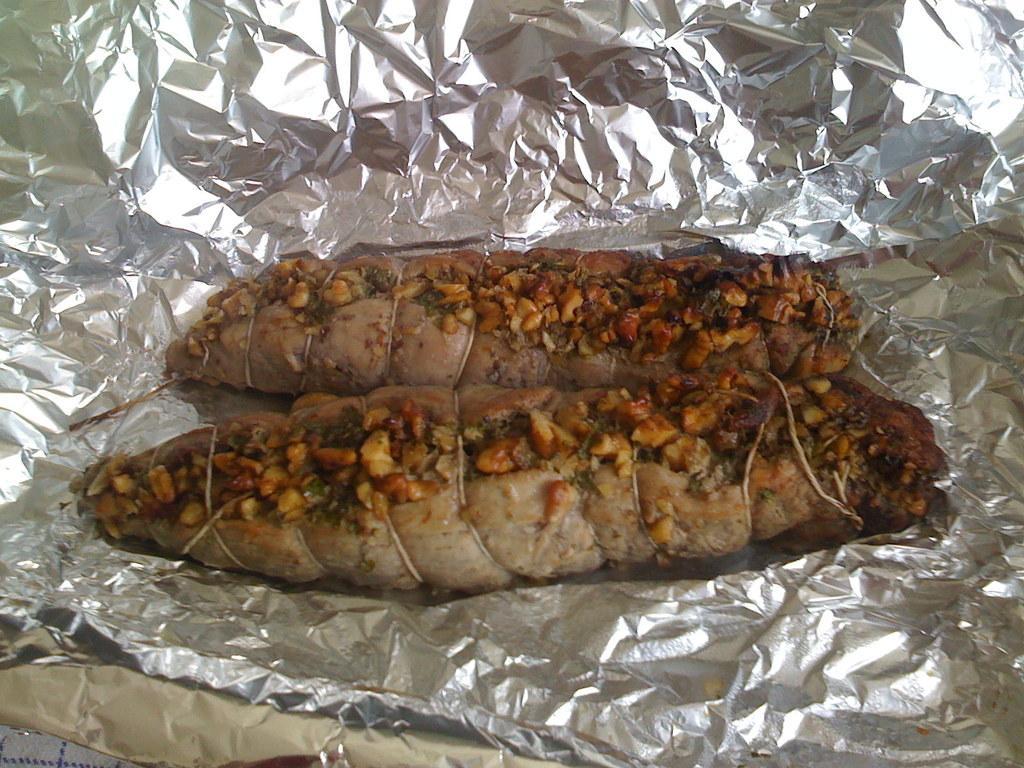Please provide a concise description of this image. In this picture we can see food on the paper. 